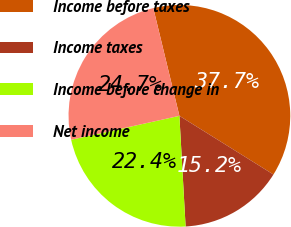Convert chart to OTSL. <chart><loc_0><loc_0><loc_500><loc_500><pie_chart><fcel>Income before taxes<fcel>Income taxes<fcel>Income before change in<fcel>Net income<nl><fcel>37.66%<fcel>15.23%<fcel>22.43%<fcel>24.68%<nl></chart> 